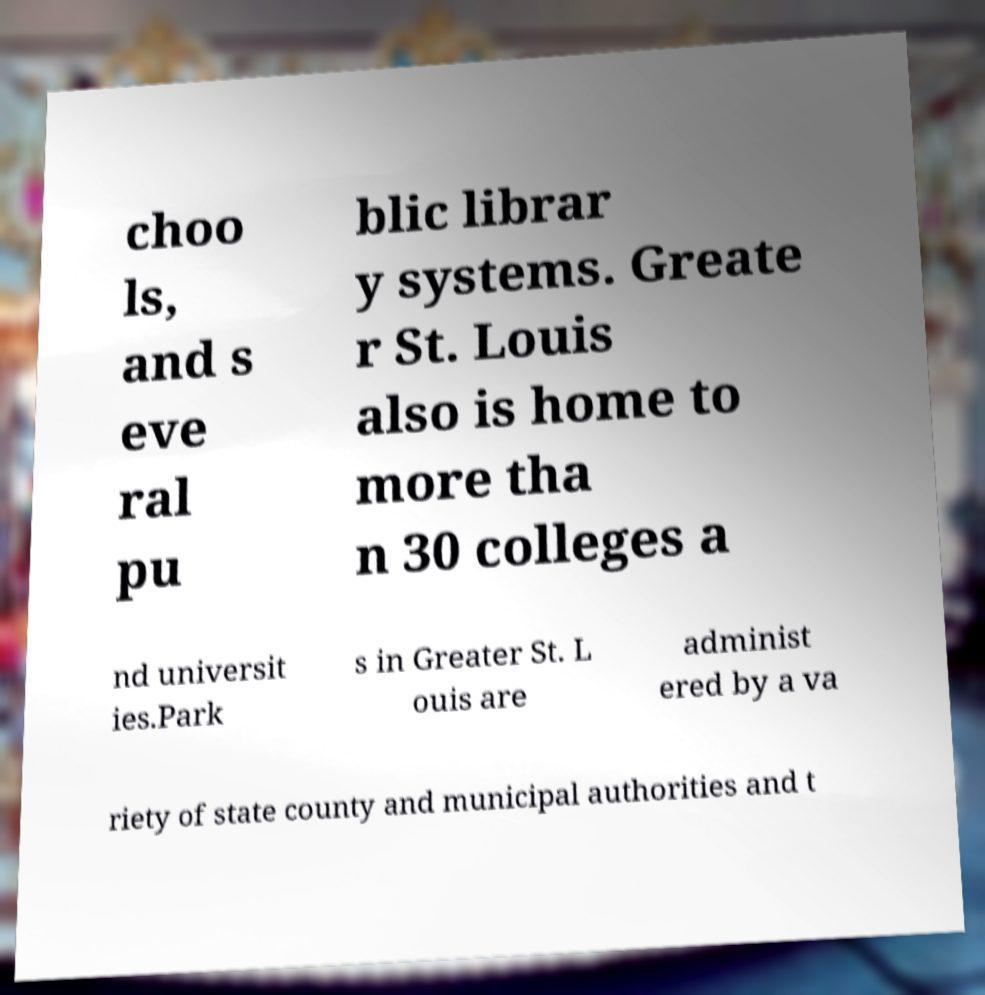There's text embedded in this image that I need extracted. Can you transcribe it verbatim? choo ls, and s eve ral pu blic librar y systems. Greate r St. Louis also is home to more tha n 30 colleges a nd universit ies.Park s in Greater St. L ouis are administ ered by a va riety of state county and municipal authorities and t 